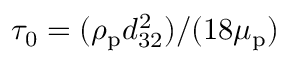Convert formula to latex. <formula><loc_0><loc_0><loc_500><loc_500>\tau _ { 0 } = ( \rho _ { p } d _ { 3 2 } ^ { 2 } ) / ( 1 8 \mu _ { p } )</formula> 